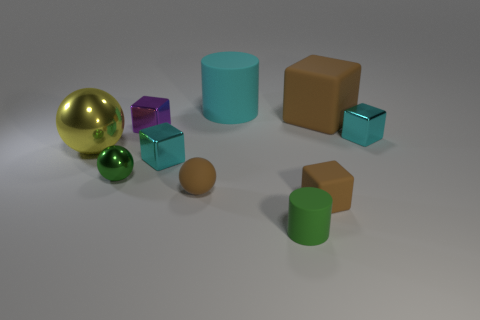How many tiny cyan shiny blocks are to the right of the brown rubber cube behind the purple metal cube?
Offer a very short reply. 1. How many other objects are the same shape as the tiny purple metallic object?
Your answer should be very brief. 4. How many objects are tiny purple rubber cylinders or spheres on the right side of the large yellow thing?
Ensure brevity in your answer.  2. Is the number of tiny blocks that are behind the small green metallic ball greater than the number of metal spheres that are behind the cyan matte object?
Keep it short and to the point. Yes. There is a tiny cyan object left of the cyan metal block to the right of the tiny cyan object that is left of the tiny matte cylinder; what shape is it?
Offer a very short reply. Cube. There is a small cyan thing behind the metallic ball that is on the left side of the green metallic thing; what is its shape?
Keep it short and to the point. Cube. Is there a tiny brown block made of the same material as the large ball?
Your answer should be compact. No. There is another matte cube that is the same color as the tiny rubber cube; what size is it?
Provide a succinct answer. Large. What number of purple objects are either tiny metallic things or metallic blocks?
Offer a terse response. 1. Is there a tiny metallic object of the same color as the large matte cylinder?
Keep it short and to the point. Yes. 